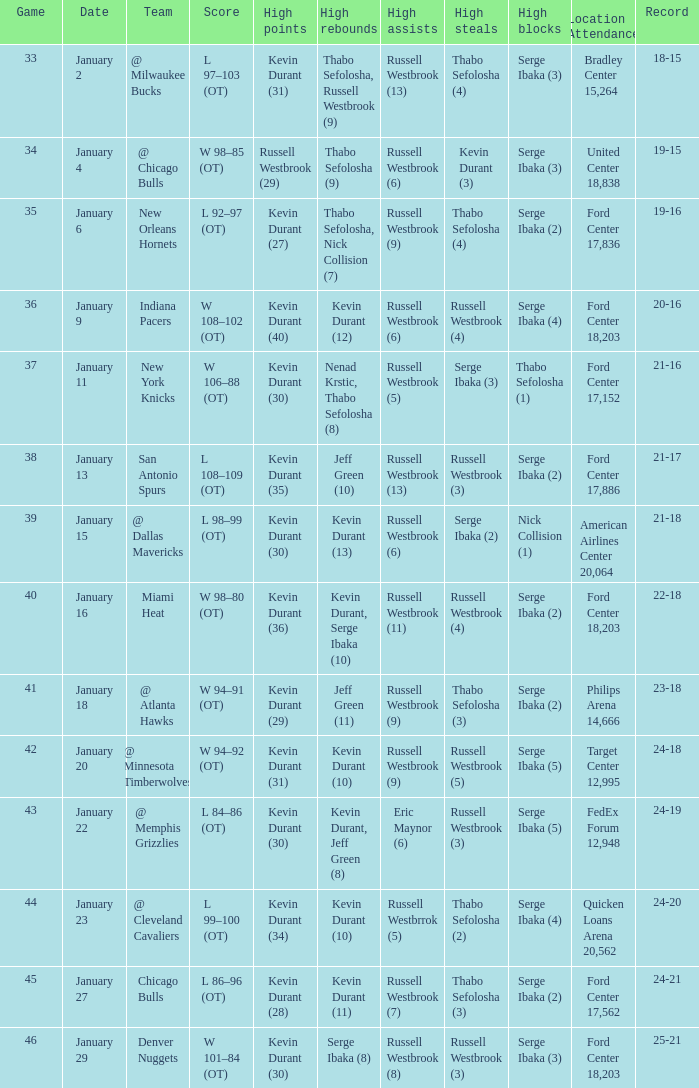Name the team for january 4 @ Chicago Bulls. 